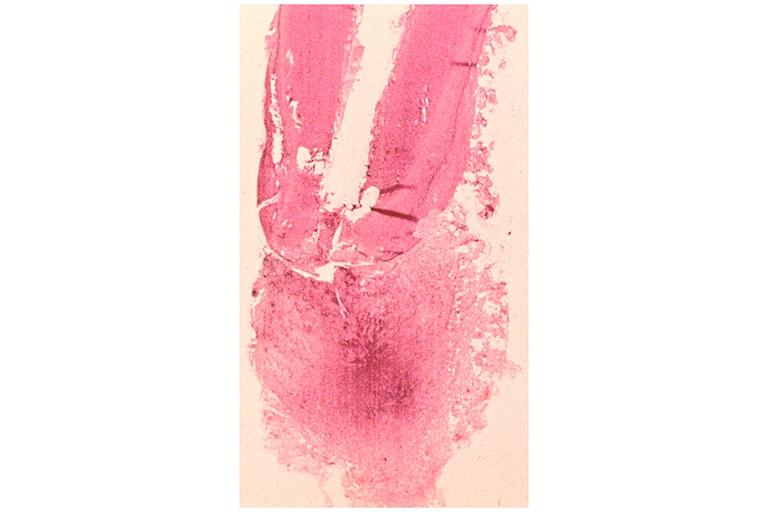does splenomegaly with cirrhosis show periapical granuloma?
Answer the question using a single word or phrase. No 